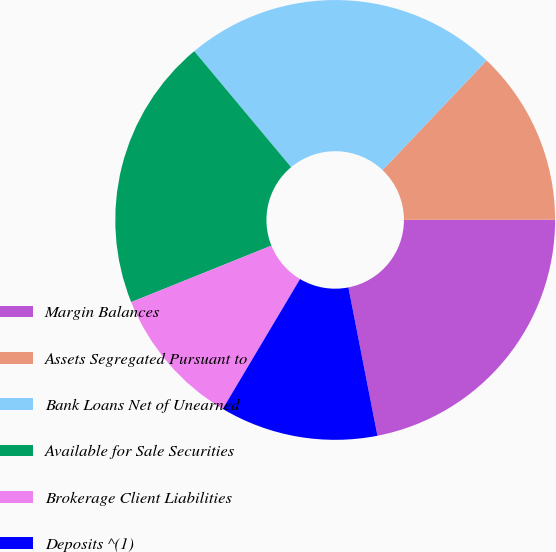Convert chart to OTSL. <chart><loc_0><loc_0><loc_500><loc_500><pie_chart><fcel>Margin Balances<fcel>Assets Segregated Pursuant to<fcel>Bank Loans Net of Unearned<fcel>Available for Sale Securities<fcel>Brokerage Client Liabilities<fcel>Deposits ^(1)<nl><fcel>21.94%<fcel>12.89%<fcel>23.16%<fcel>20.02%<fcel>10.36%<fcel>11.62%<nl></chart> 